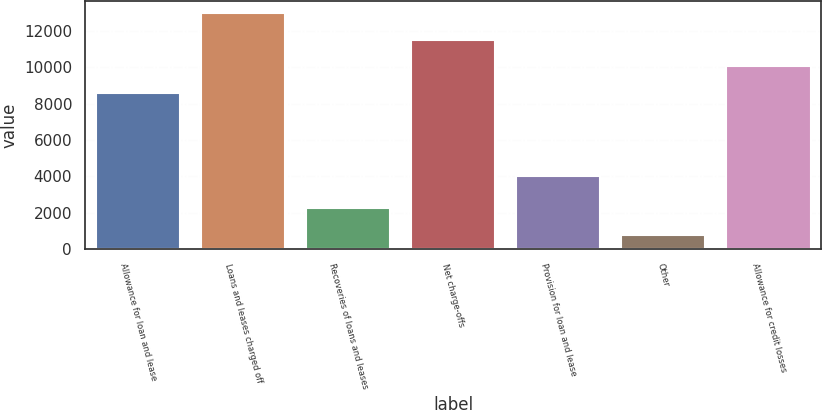<chart> <loc_0><loc_0><loc_500><loc_500><bar_chart><fcel>Allowance for loan and lease<fcel>Loans and leases charged off<fcel>Recoveries of loans and leases<fcel>Net charge-offs<fcel>Provision for loan and lease<fcel>Other<fcel>Allowance for credit losses<nl><fcel>8569<fcel>12969.1<fcel>2262.7<fcel>11502.4<fcel>4025<fcel>796<fcel>10035.7<nl></chart> 